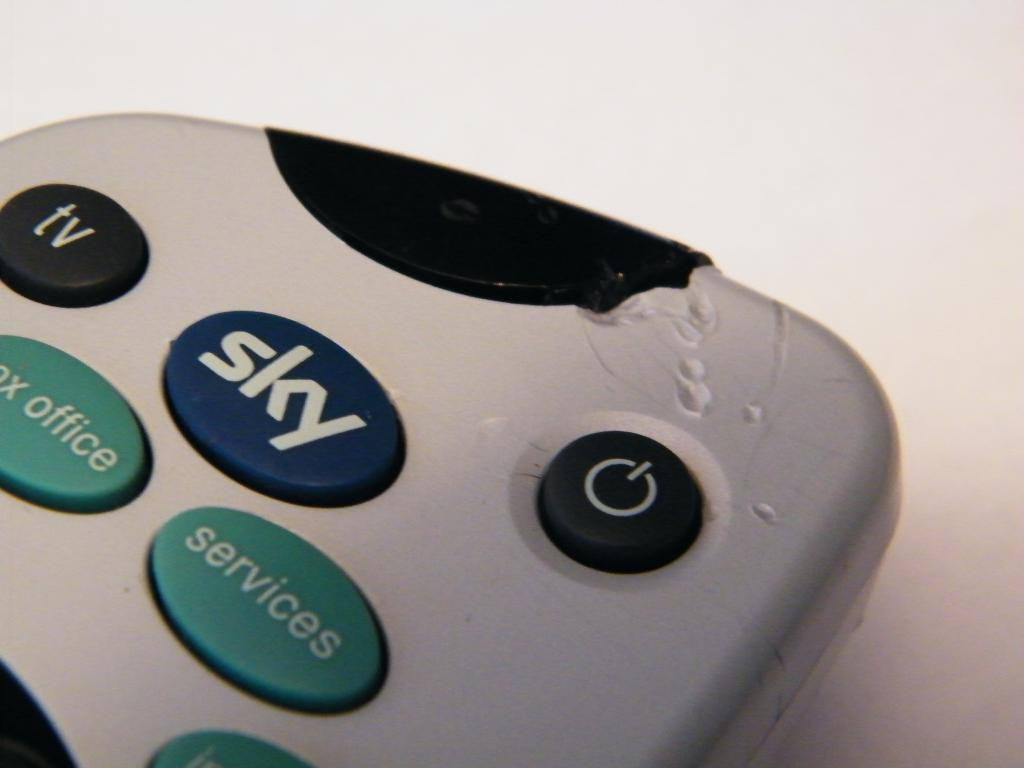<image>
Render a clear and concise summary of the photo. a remote control with tv button on the top left corner 